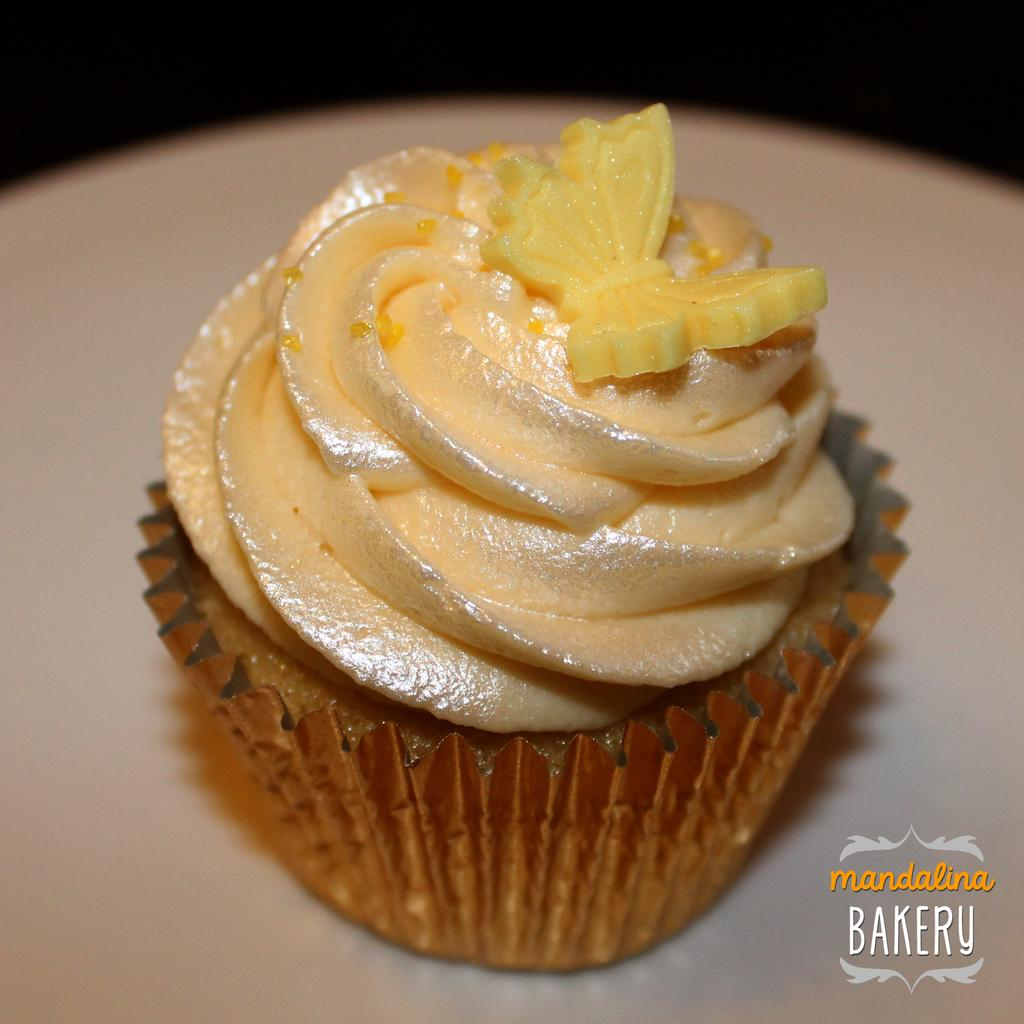What type of dessert is in the image? There is a cupcake in the image. Where is the cupcake located? The cupcake is on a table. What type of collar is on the insect in the image? There is no insect or collar present in the image. 